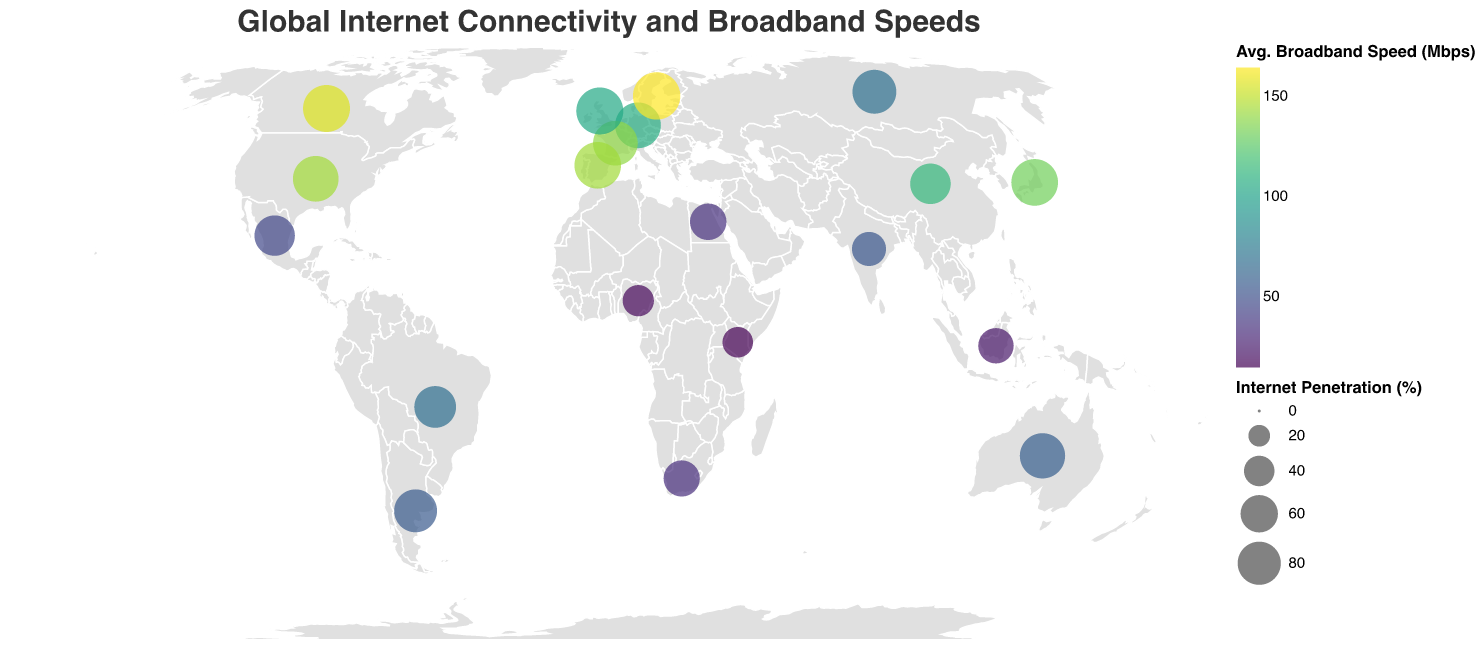what is the title of the plot? The title of the plot is typically displayed in a prominent font at the top of the figure. For this plot, it is "Global Internet Connectivity and Broadband Speeds".
Answer: Global Internet Connectivity and Broadband Speeds How many countries are represented in the plot? By counting the number of unique data points on the plot, we can see that there are 20 countries represented.
Answer: 20 Which country has the highest average broadband speed? By observing the color legend and the shading of the circles, the country with the darkest shade, representing the highest speed, is Sweden with 164.3 Mbps.
Answer: Sweden Which region has the highest internet penetration on average? To determine this, we look at the size of the circles. Western Europe, represented by Germany, France, and the United Kingdom, has high internet penetration rates (ranging from 85.6% to 94.8%). Averaging these penetration rates gives an approximate average of 90.1%. Thus, Western Europe has the highest average internet penetration.
Answer: Western Europe Which countries have rural connectivity greater than 80%? Countries with rural connectivity greater than 80% include Japan (90.2%), Canada (83.1%), Sweden (92.7%), Germany (86.3%), and the United Kingdom (88.9%) as seen by the respective data points.
Answer: Japan, Canada, Sweden, Germany, United Kingdom Which country in East Asia has the higher internet penetration? Comparing the size of the circles for countries in East Asia, Japan has a larger circle for internet penetration (93.5%) compared to China (70.4%).
Answer: Japan (93.5%) What is the difference in average broadband speed between the United States and Russia? The average broadband speed in the United States is 143.8 Mbps, and in Russia, it is 68.8 Mbps. The difference can be calculated as 143.8 - 68.8 = 75 Mbps.
Answer: 75 Mbps What are the two countries with the lowest internet penetration rates? By identifying the smallest circles which represent lower internet penetration, Kenya (40%) and Nigeria (42%) have the lowest internet penetration rates.
Answer: Kenya, Nigeria Which country in North Africa is represented in the plot, and what is its internet penetration? From the plot, the country in North Africa represented is Egypt, with an internet penetration rate of 57.3%.
Answer: Egypt (57.3%) How does the rural connectivity in Australia compare to that in Russia? The rural connectivity in Australia is 79.5%, while in Russia it is 61.4%. Comparing these values, Australia has a higher rural connectivity percentage.
Answer: Australia has higher rural connectivity 